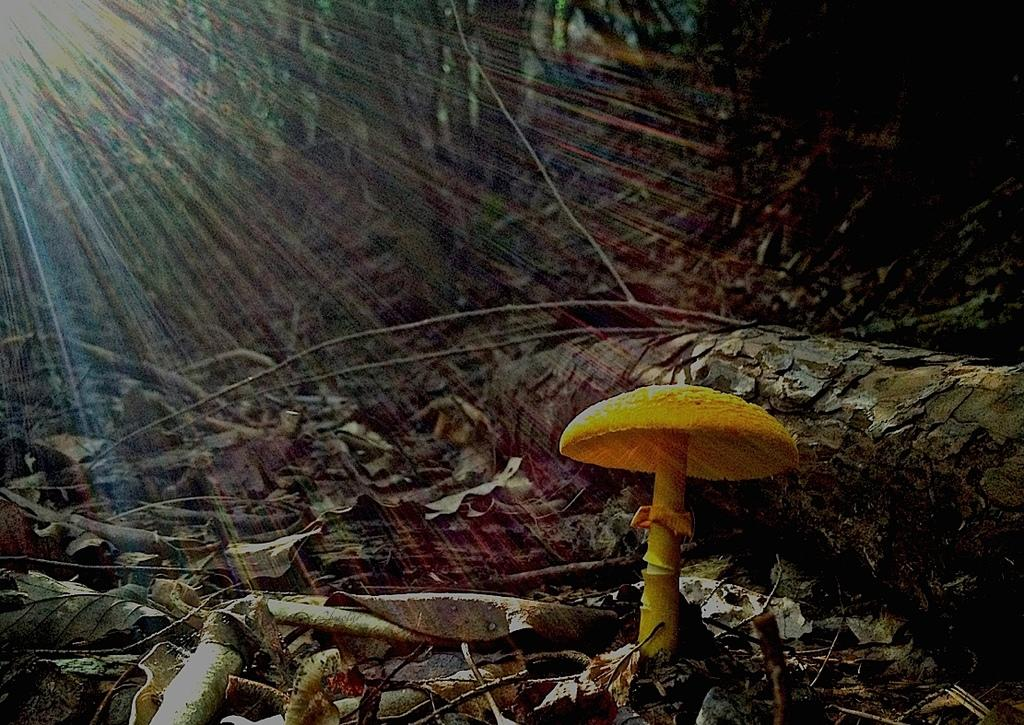What is the main subject of the image? There is a mushroom in the image. What can be seen on the ground in the image? There are dried leaves and sticks on the ground in the image. How would you describe the background of the image? The background of the image is blurry. In which direction does the tub face in the image? There is no tub present in the image. What do you believe the mushroom represents in the image? The purpose or representation of the mushroom cannot be determined from the image alone, as it is a subjective interpretation. 